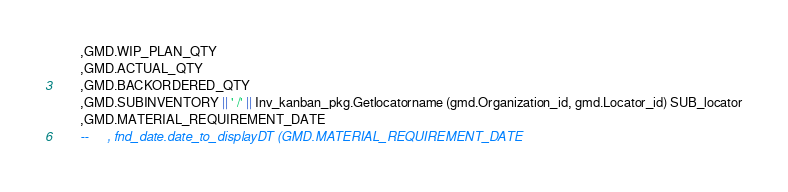<code> <loc_0><loc_0><loc_500><loc_500><_SQL_>      ,GMD.WIP_PLAN_QTY
      ,GMD.ACTUAL_QTY
      ,GMD.BACKORDERED_QTY
      ,GMD.SUBINVENTORY || ' /' || Inv_kanban_pkg.Getlocatorname (gmd.Organization_id, gmd.Locator_id) SUB_locator
      ,GMD.MATERIAL_REQUIREMENT_DATE
      --     , fnd_date.date_to_displayDT (GMD.MATERIAL_REQUIREMENT_DATE</code> 